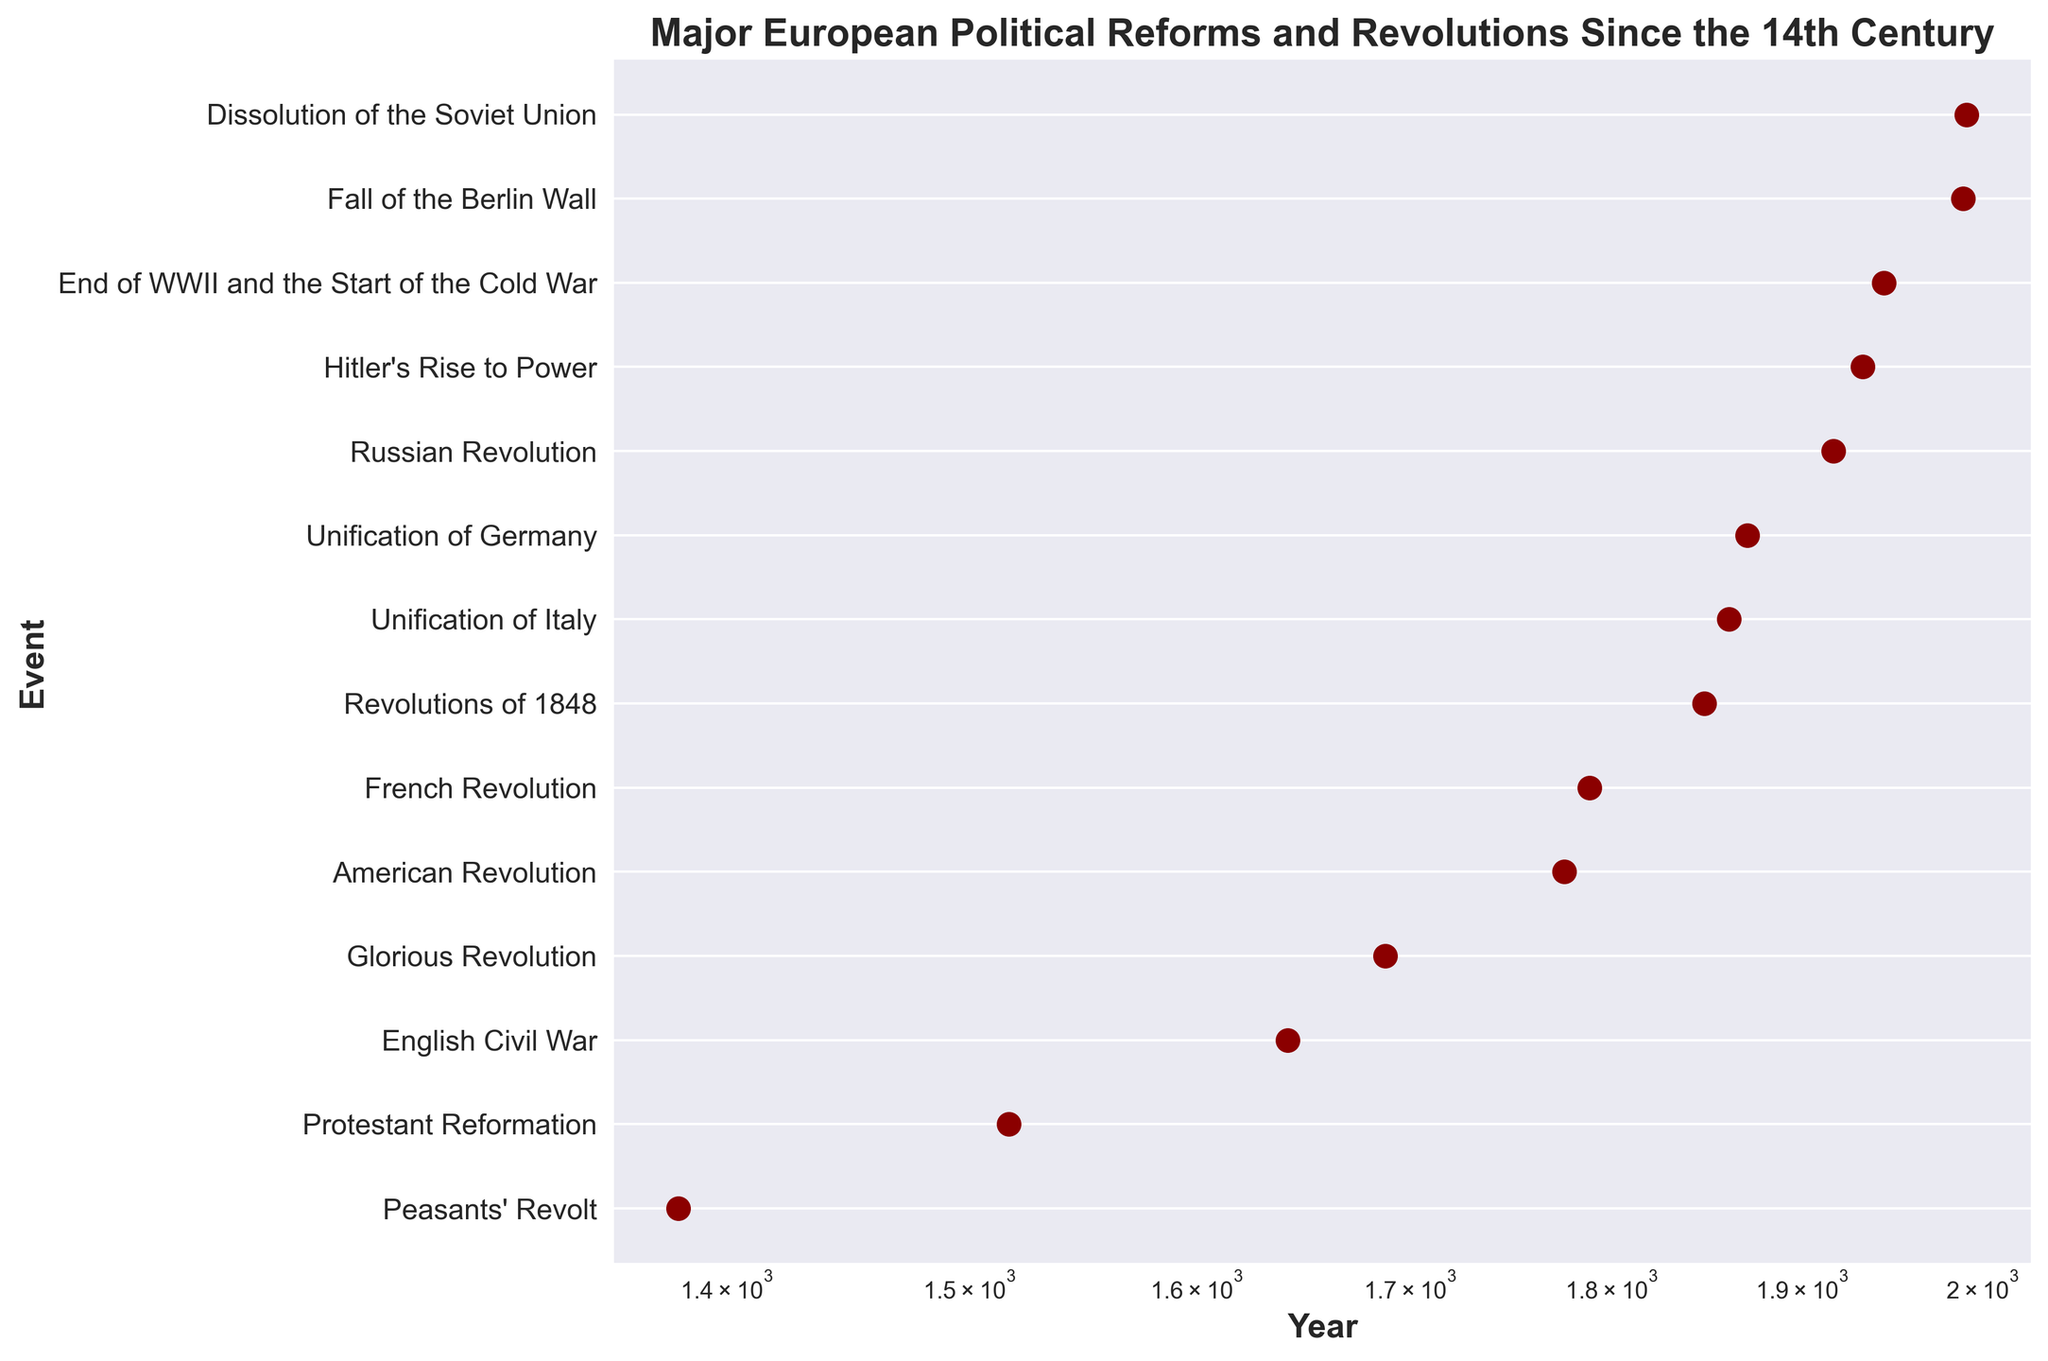When did the Protestant Reformation occur? By looking at the event "Protestant Reformation" on the y-axis and tracing horizontally to the log-scaled x-axis, we can see that it corresponds to around 1517.
Answer: 1517 Which event occurred earlier, the Peasants' Revolt or the Glorious Revolution? By comparing the positions on the x-axis, the Peasants' Revolt is to the left of the Glorious Revolution, indicating it occurred earlier.
Answer: Peasants' Revolt How many years passed between the Unification of Germany and the Russian Revolution? Subtract the year of the Unification of Germany (1871) from the year of the Russian Revolution (1917): 1917 - 1871 = 46 years.
Answer: 46 years Identify the event that took place closest to the year 1600. By looking at the events around the year 1600, we find the English Civil War closest, which occurred in 1642.
Answer: English Civil War What is the most recent event represented in the figure? By checking the rightmost point on the x-axis, we see that the Dissolution of the Soviet Union in 1991 is the most recent event.
Answer: Dissolution of the Soviet Union Which occurred first, the American Revolution or the French Revolution? By looking at the positions on the x-axis, the American Revolution (1776) is to the left of the French Revolution (1789).
Answer: American Revolution Between the English Civil War and the French Revolution, which event occurred earlier and by how many years? The English Civil War occurred in 1642, and the French Revolution in 1789. Subtract 1642 from 1789: 1789 - 1642 = 147 years.
Answer: English Civil War, by 147 years What is the median year of the events listed in the figure? To find the median year, list all the event years in order and find the middle value. Ordered years: 1381, 1517, 1642, 1688, 1776, 1789, 1848, 1861, 1871, 1917, 1933, 1945, 1989, 1991. The median year is between 1789 and 1848, so the median is (1789 + 1848) / 2 = 1818.5.
Answer: 1818.5 How many events occurred between the year 1800 and 1900? Identifying the events within this period, we find: Revolutions of 1848, Unification of Italy (1861), and Unification of Germany (1871). So, there are 3 events.
Answer: 3 events Which event is marked by a dark red color in the scatter plot? All events on the plot are marked by dark red colored markers, so the question applies to all events listed.
Answer: All events 